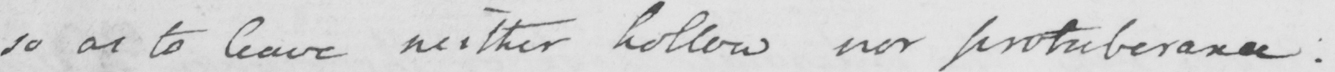Please provide the text content of this handwritten line. so as to leave neither hollow nor protuberance: 